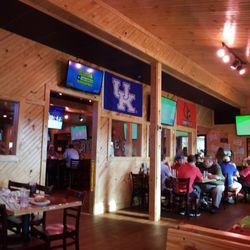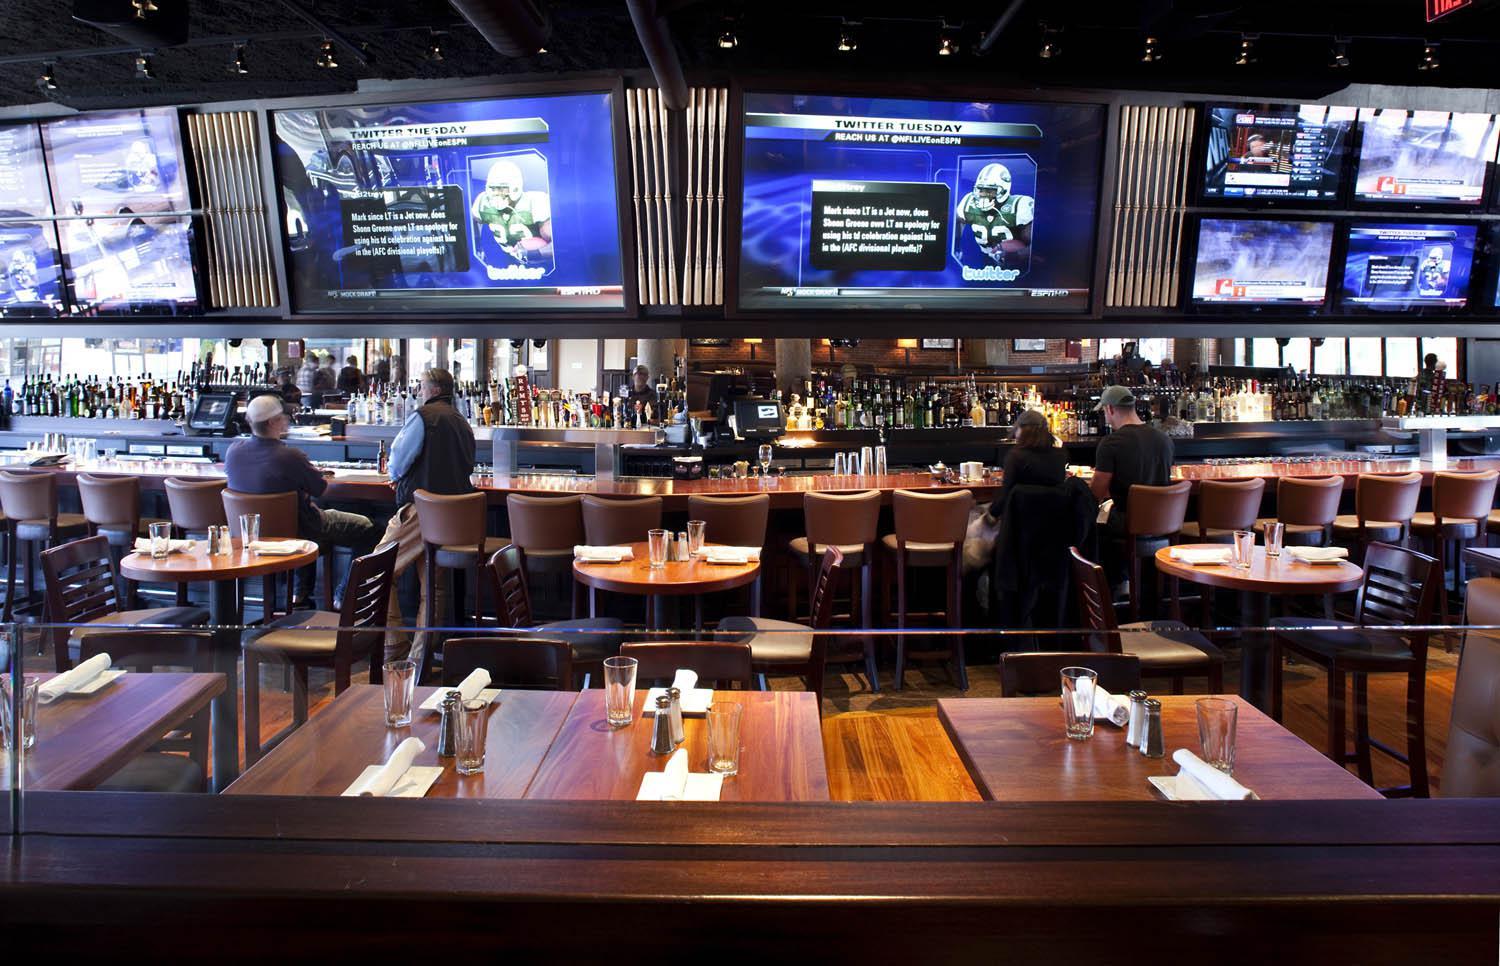The first image is the image on the left, the second image is the image on the right. Considering the images on both sides, is "There are spotlights hanging from the ceiling in one of the images." valid? Answer yes or no. Yes. The first image is the image on the left, the second image is the image on the right. Examine the images to the left and right. Is the description "In one image, the screens are in a store setting." accurate? Answer yes or no. No. 